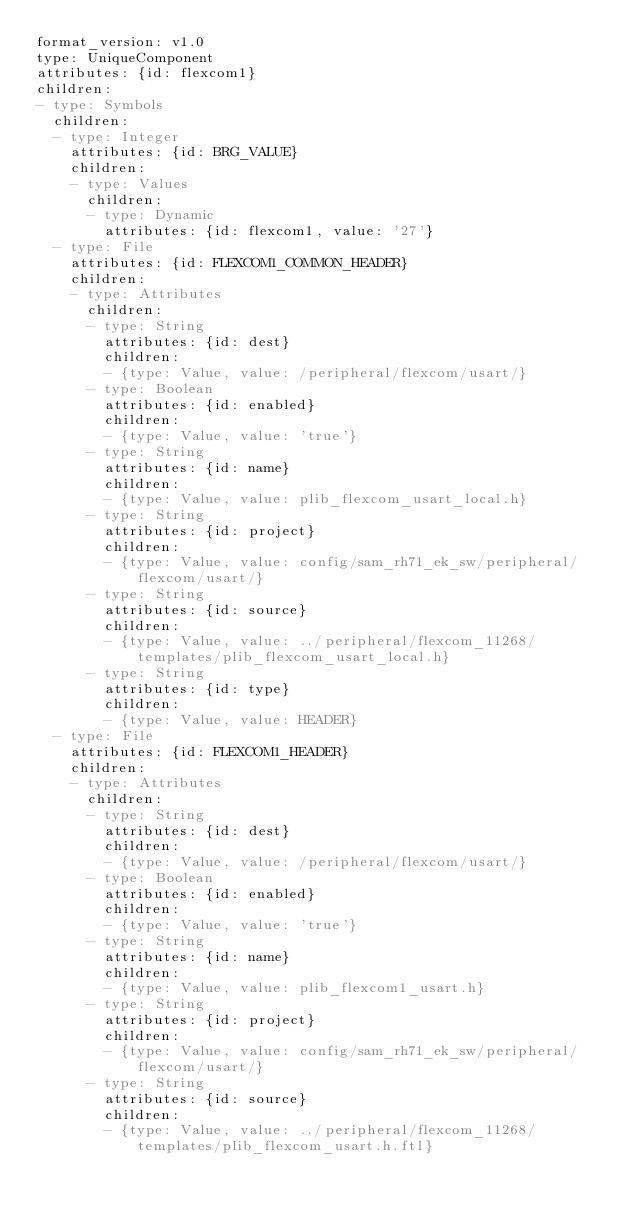Convert code to text. <code><loc_0><loc_0><loc_500><loc_500><_YAML_>format_version: v1.0
type: UniqueComponent
attributes: {id: flexcom1}
children:
- type: Symbols
  children:
  - type: Integer
    attributes: {id: BRG_VALUE}
    children:
    - type: Values
      children:
      - type: Dynamic
        attributes: {id: flexcom1, value: '27'}
  - type: File
    attributes: {id: FLEXCOM1_COMMON_HEADER}
    children:
    - type: Attributes
      children:
      - type: String
        attributes: {id: dest}
        children:
        - {type: Value, value: /peripheral/flexcom/usart/}
      - type: Boolean
        attributes: {id: enabled}
        children:
        - {type: Value, value: 'true'}
      - type: String
        attributes: {id: name}
        children:
        - {type: Value, value: plib_flexcom_usart_local.h}
      - type: String
        attributes: {id: project}
        children:
        - {type: Value, value: config/sam_rh71_ek_sw/peripheral/flexcom/usart/}
      - type: String
        attributes: {id: source}
        children:
        - {type: Value, value: ../peripheral/flexcom_11268/templates/plib_flexcom_usart_local.h}
      - type: String
        attributes: {id: type}
        children:
        - {type: Value, value: HEADER}
  - type: File
    attributes: {id: FLEXCOM1_HEADER}
    children:
    - type: Attributes
      children:
      - type: String
        attributes: {id: dest}
        children:
        - {type: Value, value: /peripheral/flexcom/usart/}
      - type: Boolean
        attributes: {id: enabled}
        children:
        - {type: Value, value: 'true'}
      - type: String
        attributes: {id: name}
        children:
        - {type: Value, value: plib_flexcom1_usart.h}
      - type: String
        attributes: {id: project}
        children:
        - {type: Value, value: config/sam_rh71_ek_sw/peripheral/flexcom/usart/}
      - type: String
        attributes: {id: source}
        children:
        - {type: Value, value: ../peripheral/flexcom_11268/templates/plib_flexcom_usart.h.ftl}</code> 